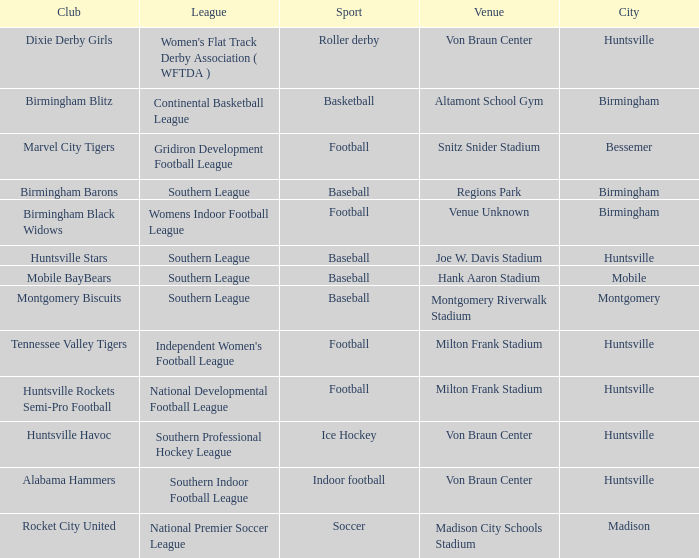Which sport had the club of the Montgomery Biscuits? Baseball. 